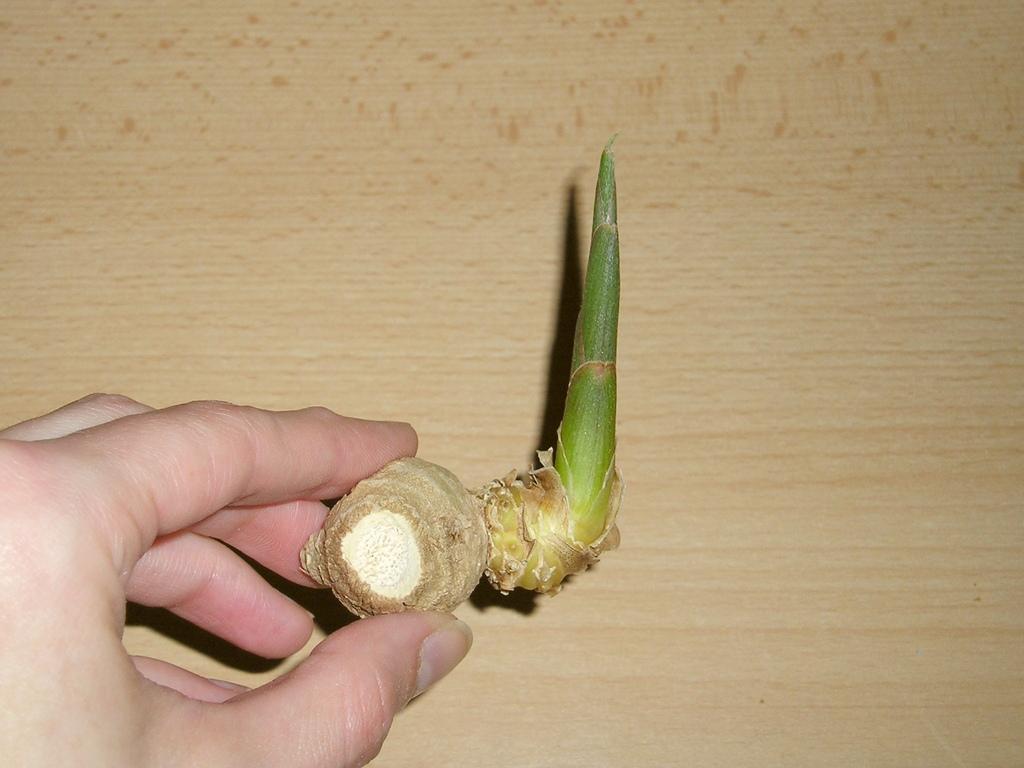Describe this image in one or two sentences. In the center of this picture we can see the hand of a person holding an object seems to be the ginger. In the background we can see a wooden object. 